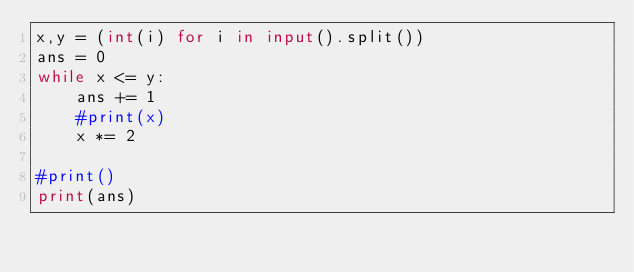Convert code to text. <code><loc_0><loc_0><loc_500><loc_500><_Python_>x,y = (int(i) for i in input().split())
ans = 0
while x <= y:
    ans += 1
    #print(x)
    x *= 2

#print()
print(ans)
</code> 